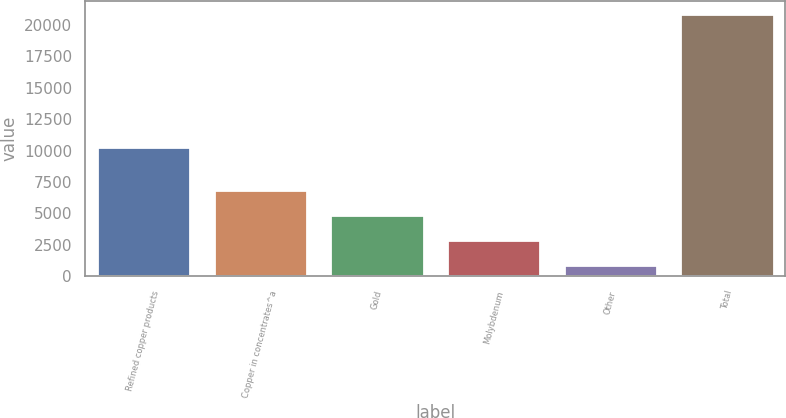Convert chart. <chart><loc_0><loc_0><loc_500><loc_500><bar_chart><fcel>Refined copper products<fcel>Copper in concentrates^a<fcel>Gold<fcel>Molybdenum<fcel>Other<fcel>Total<nl><fcel>10297<fcel>6871.6<fcel>4870.4<fcel>2869.2<fcel>868<fcel>20880<nl></chart> 